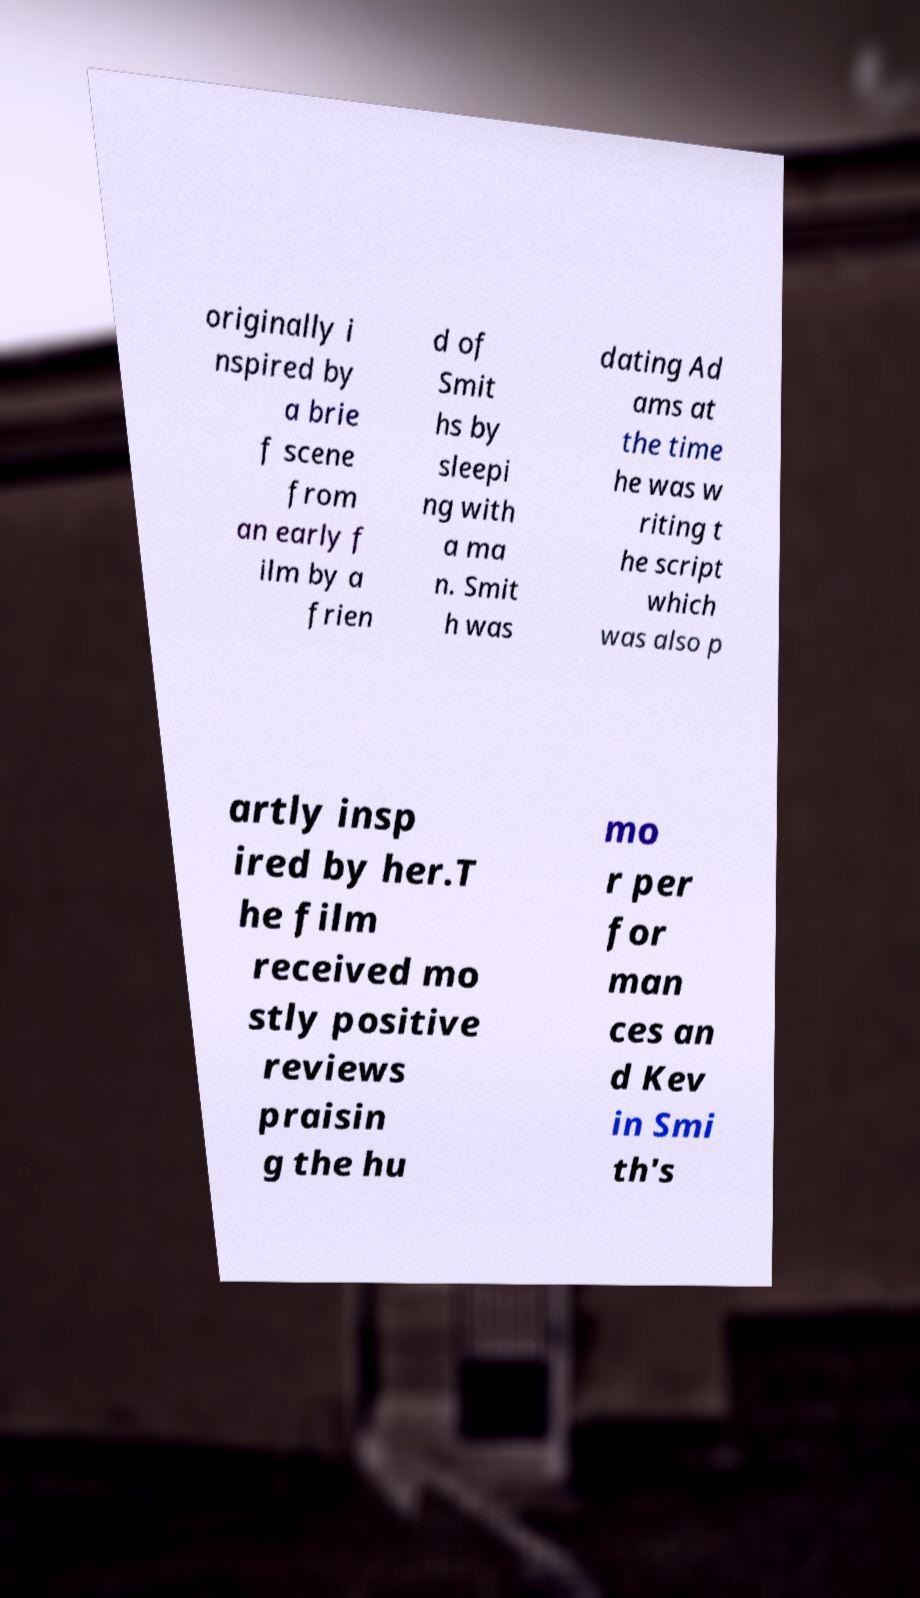Can you read and provide the text displayed in the image?This photo seems to have some interesting text. Can you extract and type it out for me? originally i nspired by a brie f scene from an early f ilm by a frien d of Smit hs by sleepi ng with a ma n. Smit h was dating Ad ams at the time he was w riting t he script which was also p artly insp ired by her.T he film received mo stly positive reviews praisin g the hu mo r per for man ces an d Kev in Smi th's 